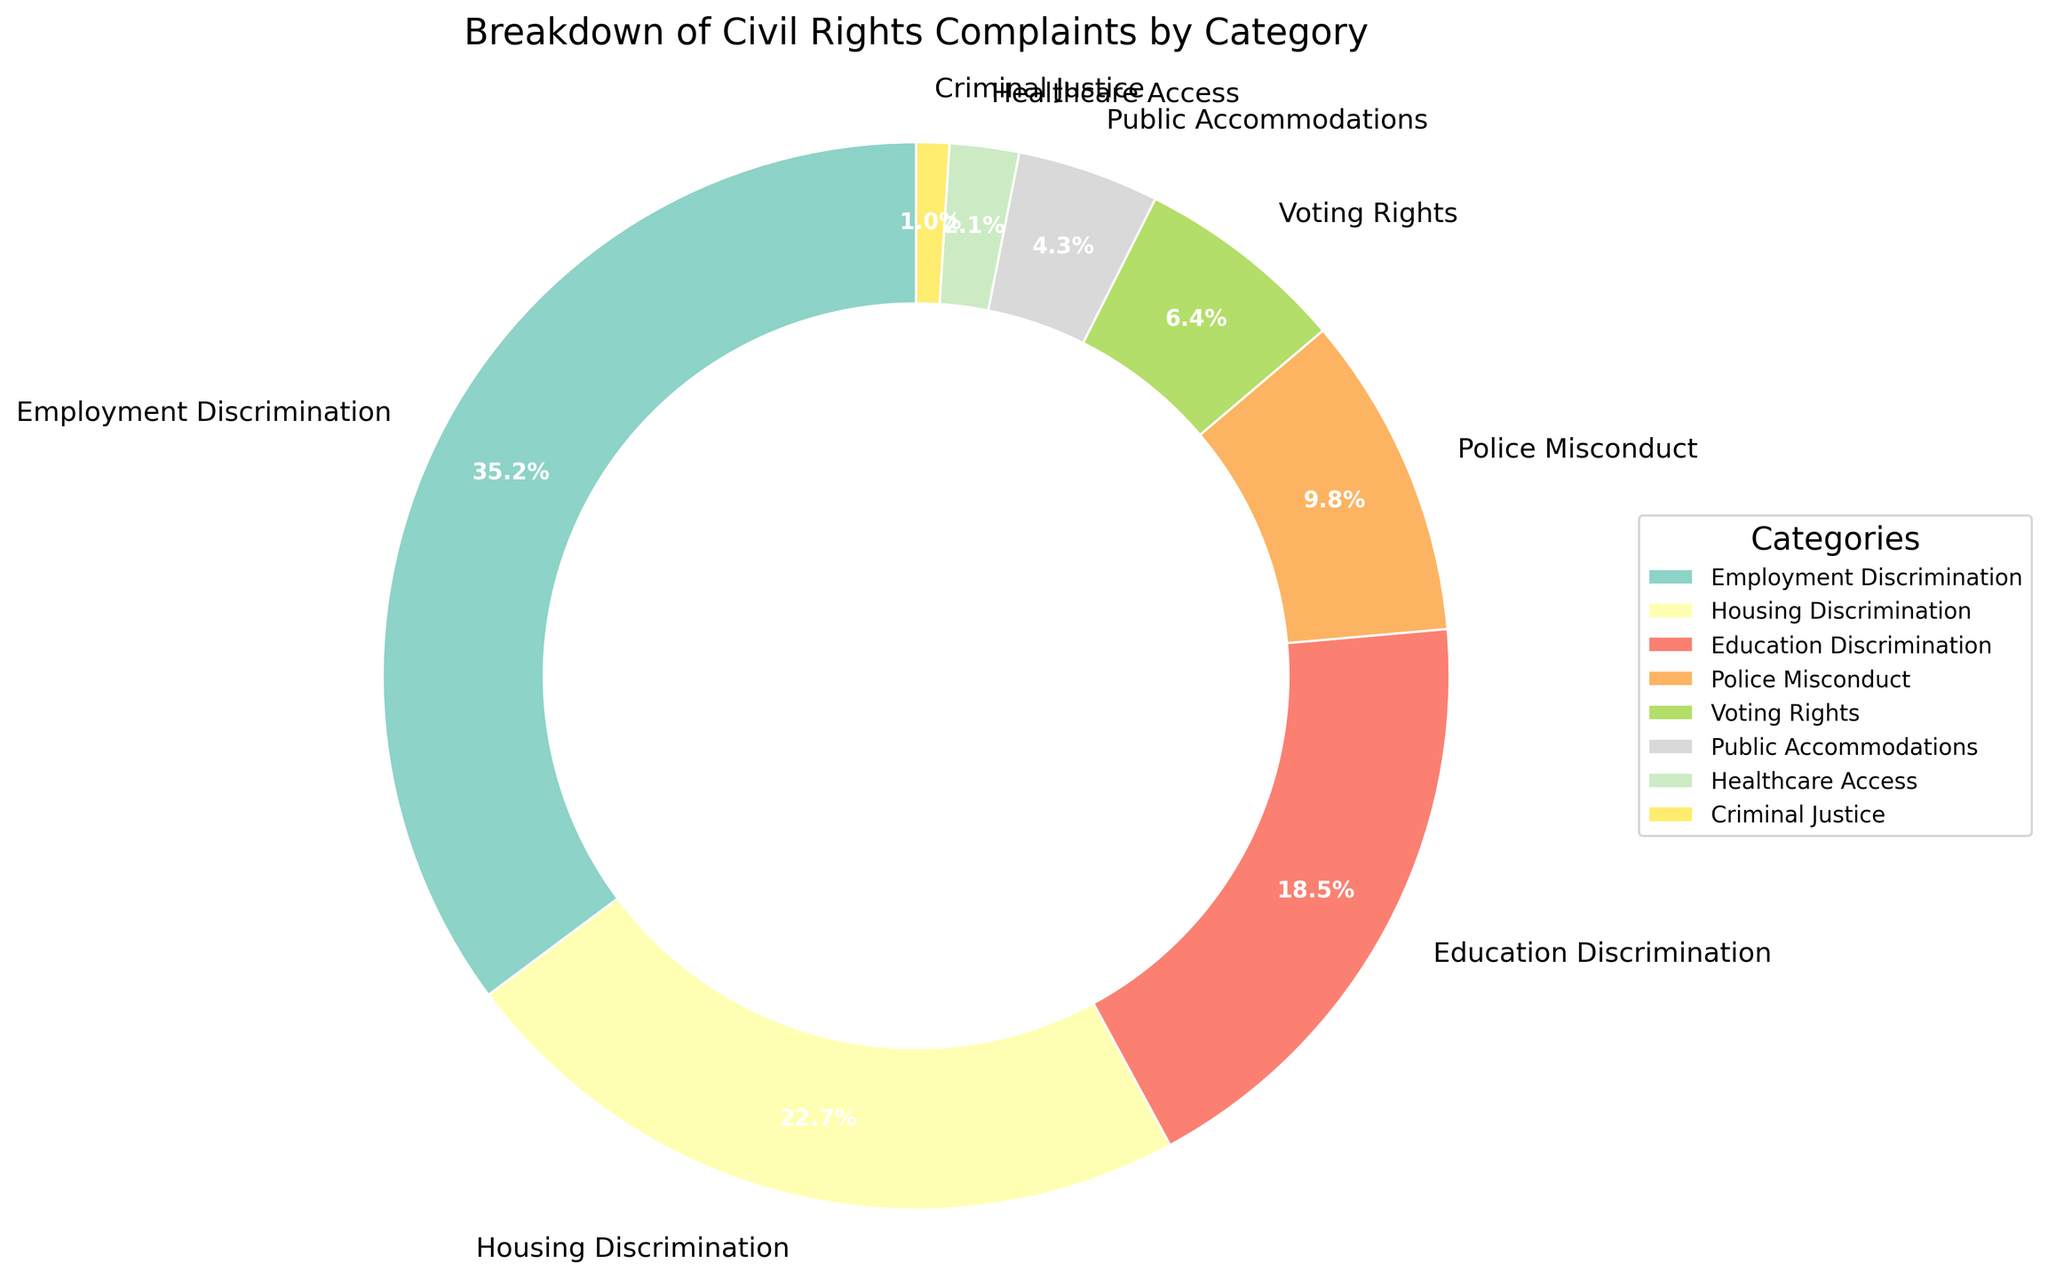What category has the highest percentage of civil rights complaints? The pie chart shows the segments of different categories. Employment Discrimination has the largest segment indicating the highest percentage.
Answer: Employment Discrimination Which category has a higher percentage of complaints: Housing Discrimination or Education Discrimination? Compare the segments of Housing Discrimination and Education Discrimination in the pie chart. Housing Discrimination's segment is larger than Education Discrimination's.
Answer: Housing Discrimination What is the combined percentage of complaints related to Healthcare Access and Criminal Justice? Add the percentages for Healthcare Access and Criminal Justice. Healthcare Access is 2.1% and Criminal Justice is 1.0%. Their combined percentage is 2.1% + 1.0% = 3.1%
Answer: 3.1% How much greater is the percentage of Employment Discrimination complaints compared to Public Accommodations? Find the difference between the percentages of Employment Discrimination (35.2%) and Public Accommodations (4.3%). 35.2% - 4.3% = 30.9%
Answer: 30.9% What is the smallest category in terms of percentage? Refer to the pie chart to identify the smallest segment. Criminal Justice has the smallest segment at 1.0%.
Answer: Criminal Justice Is the percentage of complaints in Education Discrimination more than half of the percentage in Housing Discrimination? Compare half of the percentage of Housing Discrimination (22.7%) which is 11.35% to Education Discrimination (18.5%). 18.5% is greater than 11.35%.
Answer: Yes Are there more complaints categorized under Police Misconduct or Voting Rights? Compare the segments of Police Misconduct (9.8%) and Voting Rights (6.4%) in the pie chart. Police Misconduct has a larger segment.
Answer: Police Misconduct What is the total percentage of complaints from categories with less than 10% each? Add percentages for Police Misconduct (9.8%), Voting Rights (6.4%), Public Accommodations (4.3%), Healthcare Access (2.1%), and Criminal Justice (1.0%). 9.8% + 6.4% + 4.3% + 2.1% + 1.0% = 23.6%
Answer: 23.6% Which category has a percentage of complaints closest to 20%? Look at the segments around 20%. Education Discrimination is 18.5%, which is the closest to 20%.
Answer: Education Discrimination 